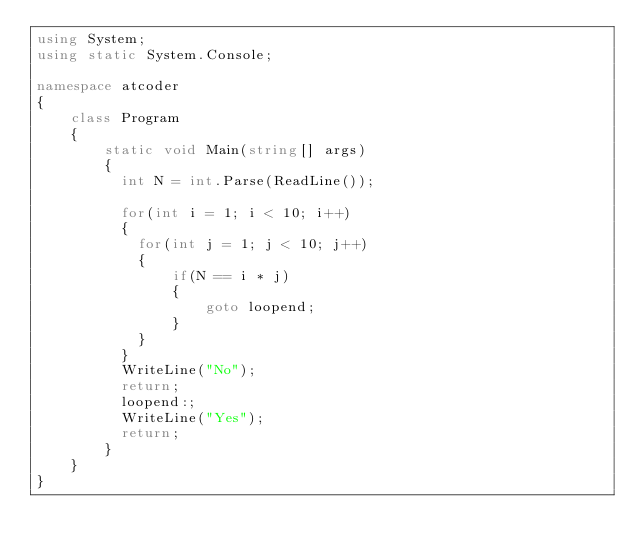<code> <loc_0><loc_0><loc_500><loc_500><_C#_>using System;
using static System.Console;

namespace atcoder
{
	class Program
    {
    	static void Main(string[] args)
        {
          int N = int.Parse(ReadLine());
          	
          for(int i = 1; i < 10; i++)
          {
          	for(int j = 1; j < 10; j++)
            {
            	if(N == i * j)
                {
                	goto loopend;
                }
            }
          }
          WriteLine("No");
          return;
          loopend:;
          WriteLine("Yes");
          return;
        }
    }
}</code> 